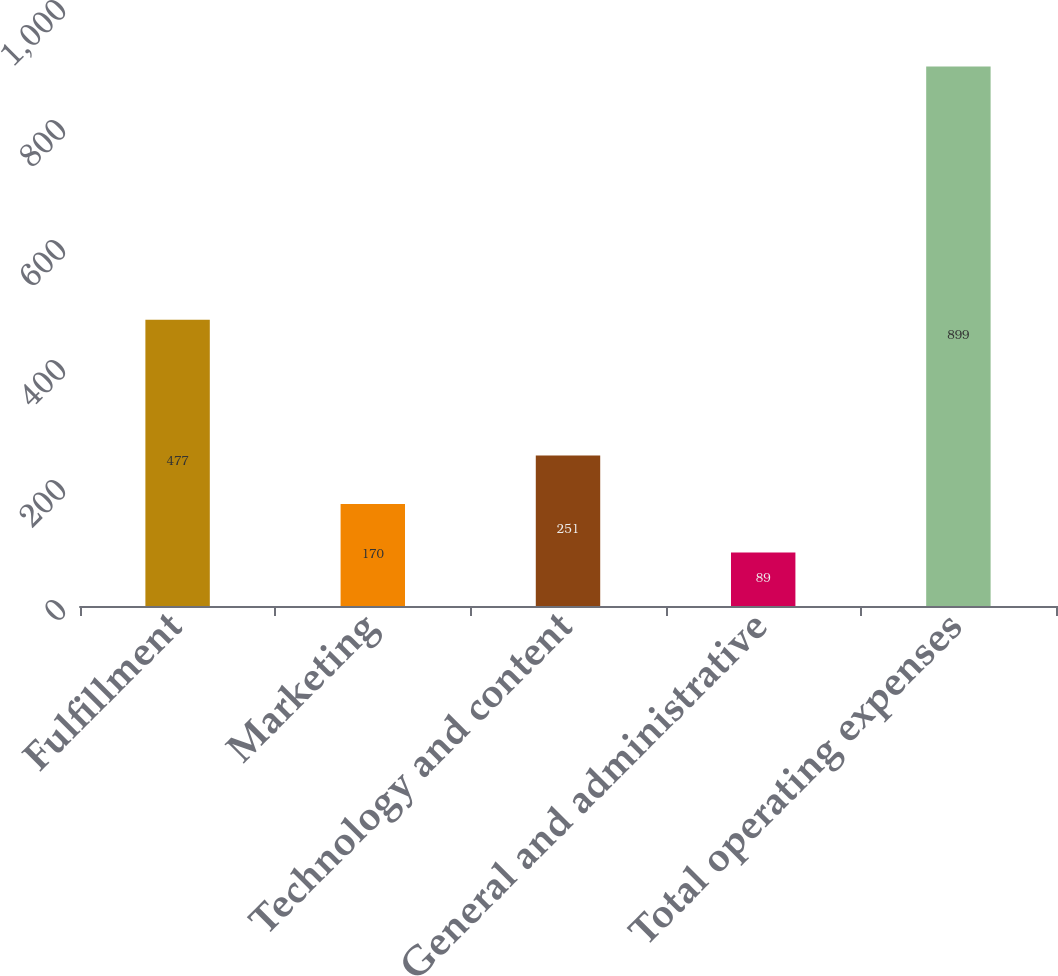<chart> <loc_0><loc_0><loc_500><loc_500><bar_chart><fcel>Fulfillment<fcel>Marketing<fcel>Technology and content<fcel>General and administrative<fcel>Total operating expenses<nl><fcel>477<fcel>170<fcel>251<fcel>89<fcel>899<nl></chart> 